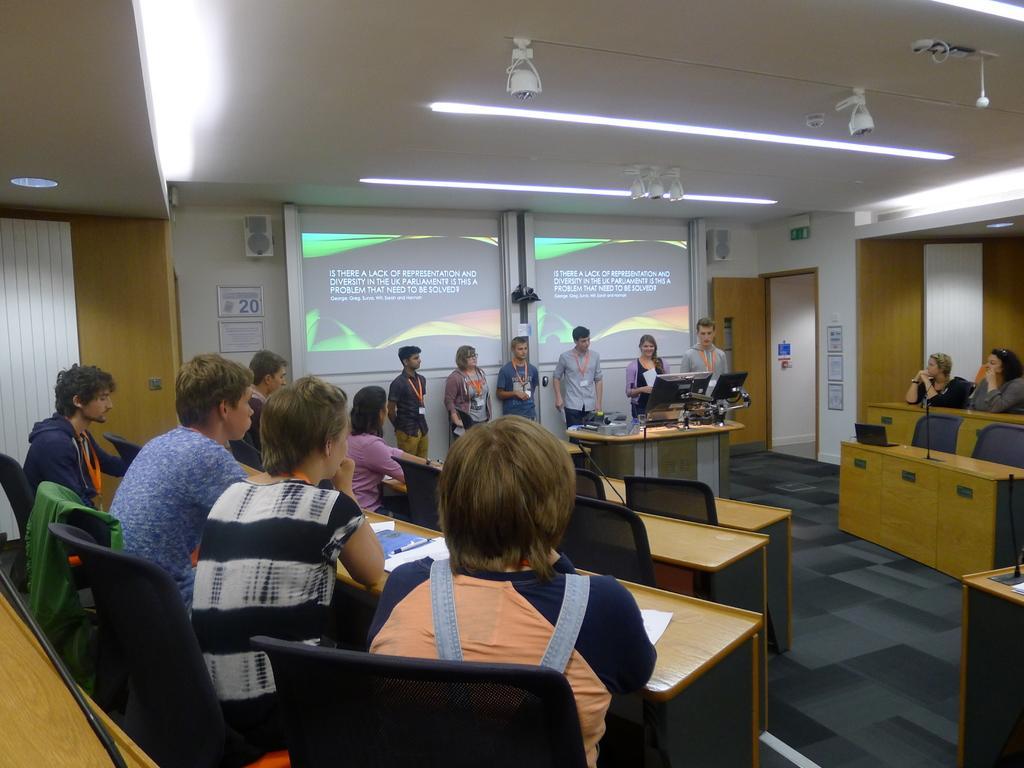How would you summarize this image in a sentence or two? Few persons are sitting on the chairs and few persons are standing. We can see tables and chairs,on the table we can see papers,book,monitors. This is floor. On the background we can see screens,wall,door. On the top we can see lights. 